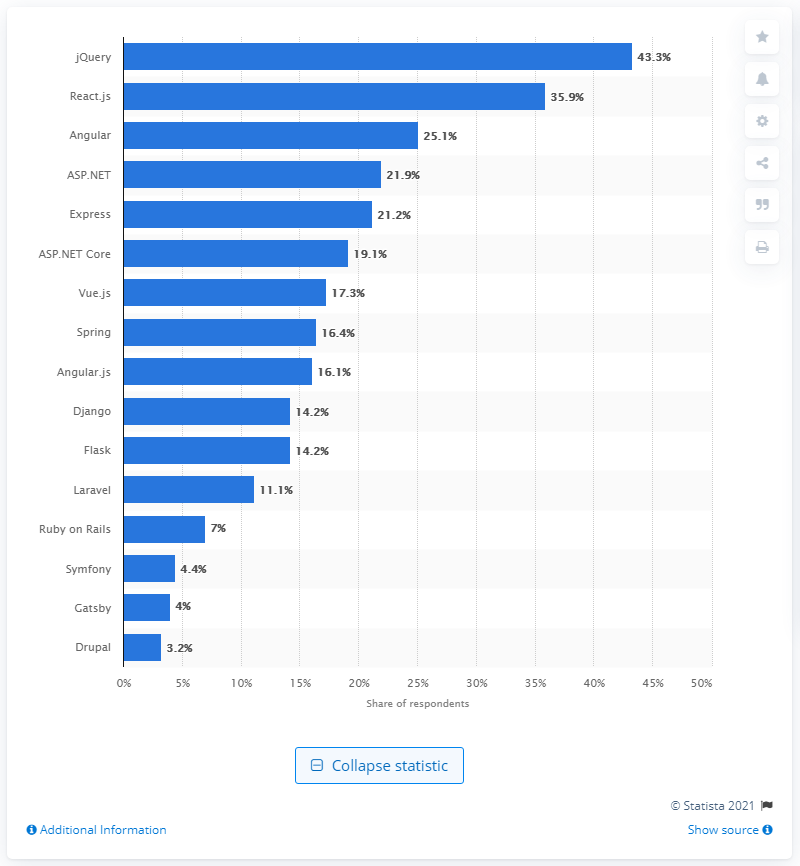What can you tell me about the least popular technology listed? The technology with the least popularity on this chart is 'Drupal,' with a 3.2% share of respondents. 